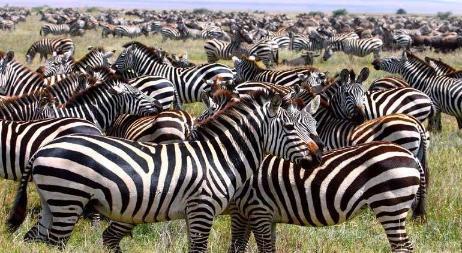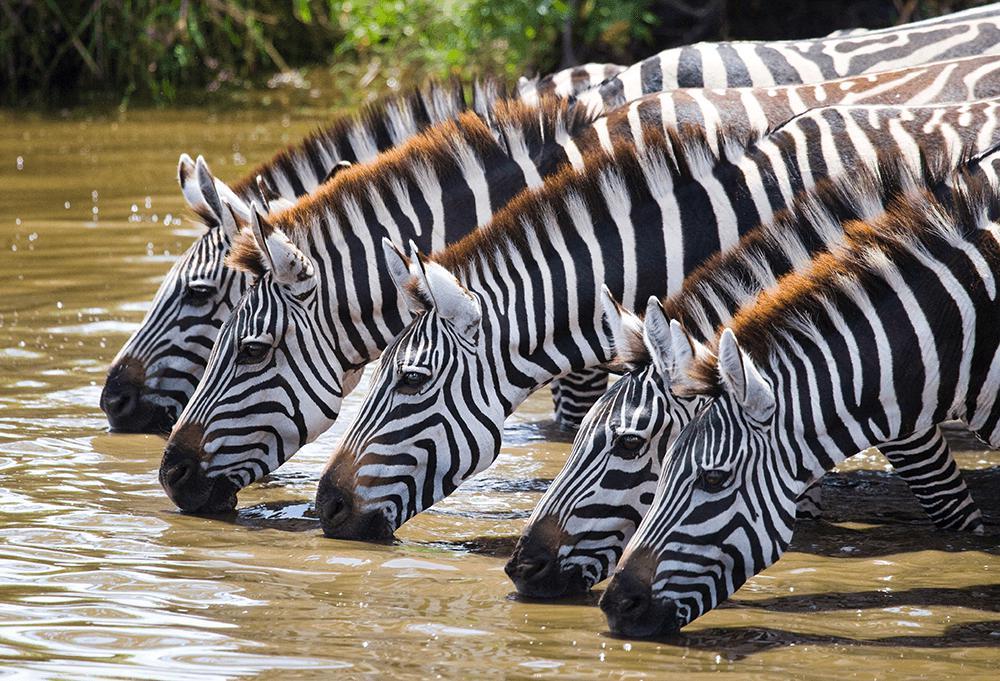The first image is the image on the left, the second image is the image on the right. Considering the images on both sides, is "The zebras in one of the images are drinking from a body of water." valid? Answer yes or no. Yes. The first image is the image on the left, the second image is the image on the right. For the images shown, is this caption "One image shows zebras with necks extending from the right lined up to drink, with heads bent to the water." true? Answer yes or no. Yes. 